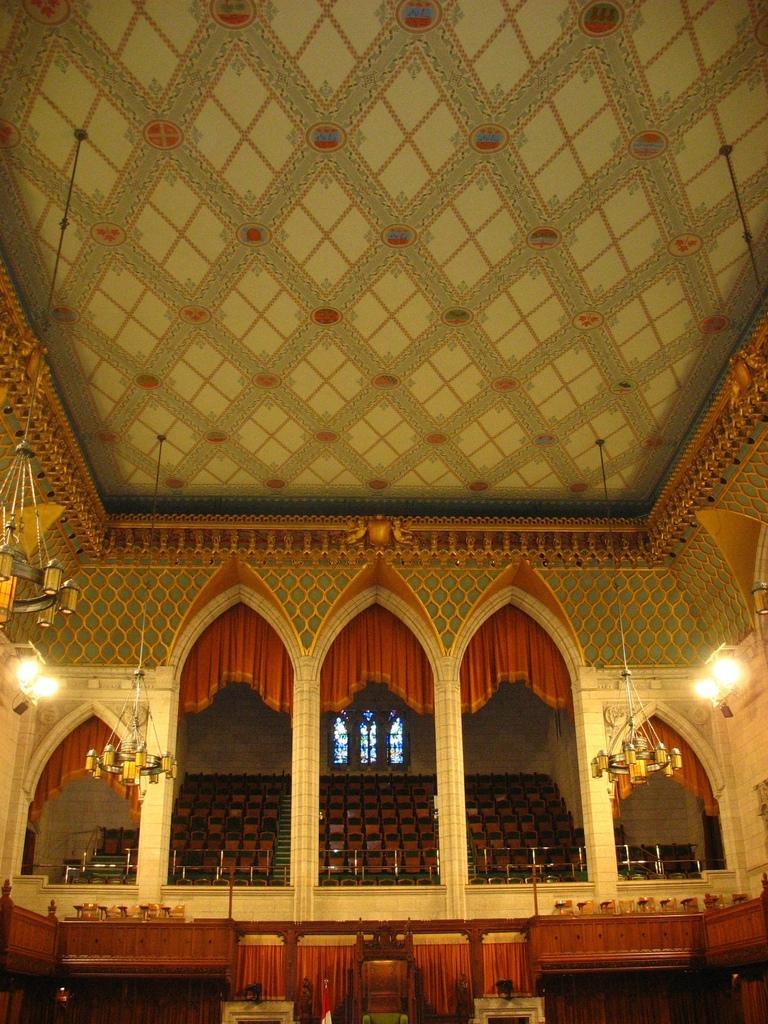In one or two sentences, can you explain what this image depicts? In this picture we can see the inside view of courtroom. In the background we can see many chairs and window. On the right we can see light and chandelier. In the bottom we can see wooden chair, flag and tables. 